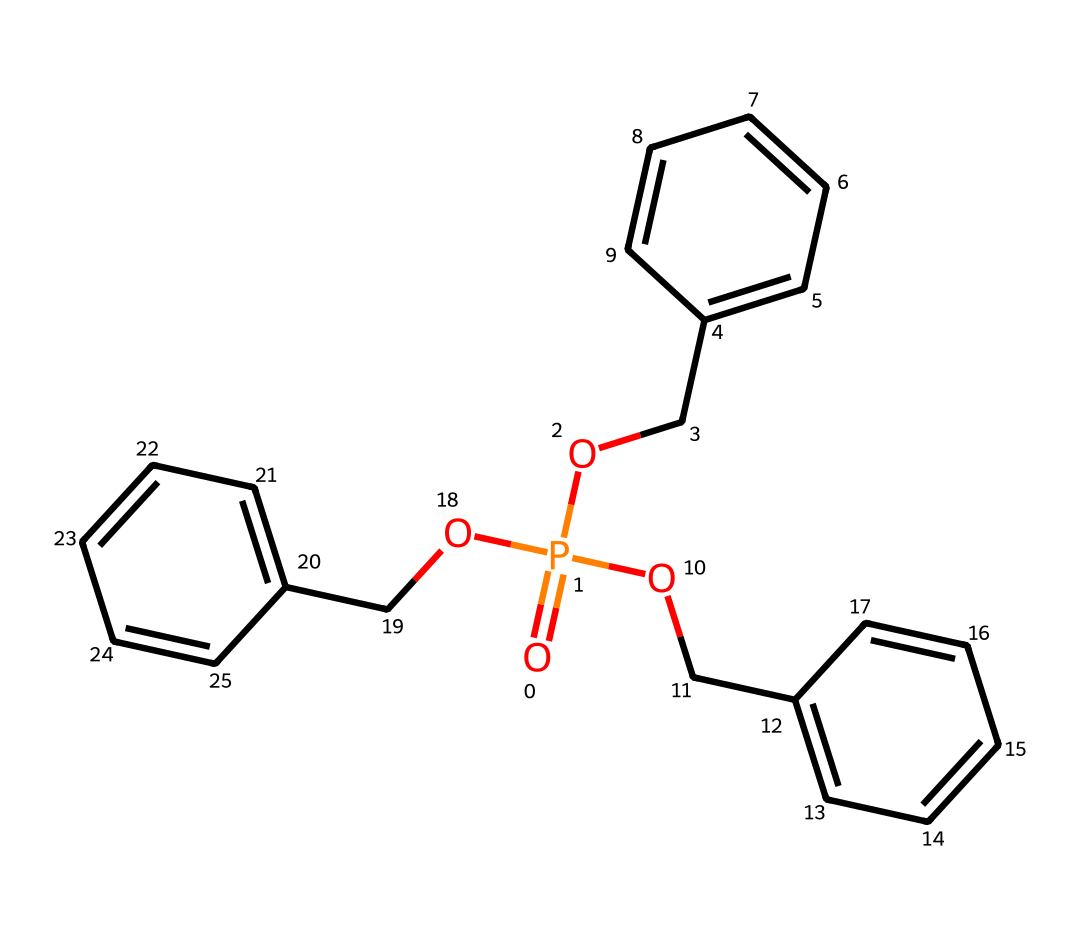What is the central atom in this compound? The central atom can be identified by looking at the structure. The phosphorus atom is situated in the center, which is typical for phosphorus compounds.
Answer: phosphorus How many aromatic rings are present in this structure? The structure features three distinct aromatic rings, which can be detected by identifying the repeating carbon atoms in a hexagonal arrangement.
Answer: three What type of chemical bond connects the phosphorus atom to the oxygen atoms? The bonds between the phosphorus and oxygen atoms are covalent bonds, indicated by the presence of the phosphorus-oxygen connection and the lack of ionic character in the structure shown.
Answer: covalent How many ethyl groups are attached to the phosphorus atom? The two ethyl groups are represented by the OCc fragments, each connecting to the phosphorus. Counting these groups leads to a total of three ethyl groups.
Answer: three Is this compound likely to be hydrophobic or hydrophilic? The structure contains aromatic groups and ether linkages, suggesting that it does not interact favorably with water, thus indicating a hydrophobic nature.
Answer: hydrophobic What role does this compound serve in sports equipment manufacturing? Given its structure and the presence of phosphorus, this compound is a flame retardant, a common additive in materials used for safety in sports equipment.
Answer: flame retardant 